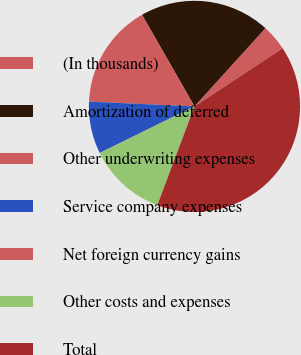<chart> <loc_0><loc_0><loc_500><loc_500><pie_chart><fcel>(In thousands)<fcel>Amortization of deferred<fcel>Other underwriting expenses<fcel>Service company expenses<fcel>Net foreign currency gains<fcel>Other costs and expenses<fcel>Total<nl><fcel>4.0%<fcel>20.0%<fcel>16.0%<fcel>8.0%<fcel>0.0%<fcel>12.0%<fcel>40.0%<nl></chart> 